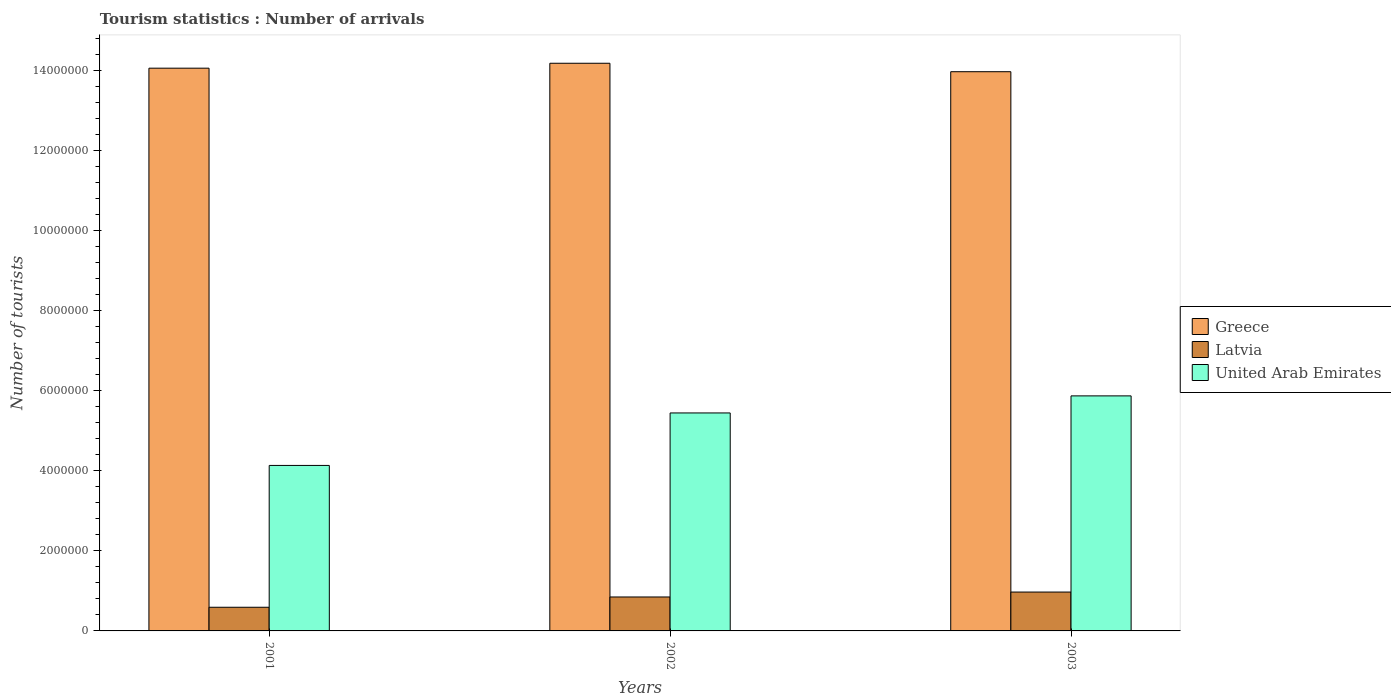How many different coloured bars are there?
Provide a short and direct response. 3. How many groups of bars are there?
Provide a succinct answer. 3. How many bars are there on the 2nd tick from the left?
Provide a short and direct response. 3. How many bars are there on the 1st tick from the right?
Make the answer very short. 3. In how many cases, is the number of bars for a given year not equal to the number of legend labels?
Offer a very short reply. 0. What is the number of tourist arrivals in United Arab Emirates in 2003?
Offer a very short reply. 5.87e+06. Across all years, what is the maximum number of tourist arrivals in Latvia?
Provide a succinct answer. 9.71e+05. Across all years, what is the minimum number of tourist arrivals in Latvia?
Your answer should be compact. 5.91e+05. In which year was the number of tourist arrivals in United Arab Emirates minimum?
Your answer should be very brief. 2001. What is the total number of tourist arrivals in Greece in the graph?
Your answer should be compact. 4.22e+07. What is the difference between the number of tourist arrivals in Latvia in 2001 and that in 2003?
Ensure brevity in your answer.  -3.80e+05. What is the difference between the number of tourist arrivals in Latvia in 2001 and the number of tourist arrivals in Greece in 2002?
Ensure brevity in your answer.  -1.36e+07. What is the average number of tourist arrivals in Greece per year?
Make the answer very short. 1.41e+07. In the year 2001, what is the difference between the number of tourist arrivals in Latvia and number of tourist arrivals in United Arab Emirates?
Provide a succinct answer. -3.54e+06. What is the ratio of the number of tourist arrivals in Latvia in 2002 to that in 2003?
Your response must be concise. 0.87. Is the number of tourist arrivals in Greece in 2001 less than that in 2002?
Your answer should be compact. Yes. Is the difference between the number of tourist arrivals in Latvia in 2001 and 2003 greater than the difference between the number of tourist arrivals in United Arab Emirates in 2001 and 2003?
Your answer should be compact. Yes. What is the difference between the highest and the second highest number of tourist arrivals in Latvia?
Your answer should be compact. 1.23e+05. What is the difference between the highest and the lowest number of tourist arrivals in United Arab Emirates?
Provide a short and direct response. 1.74e+06. Is the sum of the number of tourist arrivals in Greece in 2002 and 2003 greater than the maximum number of tourist arrivals in Latvia across all years?
Make the answer very short. Yes. How many years are there in the graph?
Provide a succinct answer. 3. Are the values on the major ticks of Y-axis written in scientific E-notation?
Your answer should be very brief. No. Does the graph contain grids?
Your answer should be very brief. No. Where does the legend appear in the graph?
Ensure brevity in your answer.  Center right. How many legend labels are there?
Offer a very short reply. 3. How are the legend labels stacked?
Offer a very short reply. Vertical. What is the title of the graph?
Provide a short and direct response. Tourism statistics : Number of arrivals. Does "Iceland" appear as one of the legend labels in the graph?
Make the answer very short. No. What is the label or title of the Y-axis?
Make the answer very short. Number of tourists. What is the Number of tourists of Greece in 2001?
Provide a succinct answer. 1.41e+07. What is the Number of tourists in Latvia in 2001?
Ensure brevity in your answer.  5.91e+05. What is the Number of tourists in United Arab Emirates in 2001?
Provide a short and direct response. 4.13e+06. What is the Number of tourists of Greece in 2002?
Make the answer very short. 1.42e+07. What is the Number of tourists of Latvia in 2002?
Provide a short and direct response. 8.48e+05. What is the Number of tourists of United Arab Emirates in 2002?
Provide a short and direct response. 5.44e+06. What is the Number of tourists in Greece in 2003?
Provide a short and direct response. 1.40e+07. What is the Number of tourists in Latvia in 2003?
Make the answer very short. 9.71e+05. What is the Number of tourists of United Arab Emirates in 2003?
Provide a succinct answer. 5.87e+06. Across all years, what is the maximum Number of tourists of Greece?
Your answer should be very brief. 1.42e+07. Across all years, what is the maximum Number of tourists of Latvia?
Your answer should be compact. 9.71e+05. Across all years, what is the maximum Number of tourists in United Arab Emirates?
Your answer should be compact. 5.87e+06. Across all years, what is the minimum Number of tourists in Greece?
Give a very brief answer. 1.40e+07. Across all years, what is the minimum Number of tourists in Latvia?
Ensure brevity in your answer.  5.91e+05. Across all years, what is the minimum Number of tourists of United Arab Emirates?
Keep it short and to the point. 4.13e+06. What is the total Number of tourists of Greece in the graph?
Your answer should be compact. 4.22e+07. What is the total Number of tourists in Latvia in the graph?
Offer a very short reply. 2.41e+06. What is the total Number of tourists in United Arab Emirates in the graph?
Keep it short and to the point. 1.54e+07. What is the difference between the Number of tourists in Greece in 2001 and that in 2002?
Offer a very short reply. -1.23e+05. What is the difference between the Number of tourists in Latvia in 2001 and that in 2002?
Offer a terse response. -2.57e+05. What is the difference between the Number of tourists of United Arab Emirates in 2001 and that in 2002?
Provide a succinct answer. -1.31e+06. What is the difference between the Number of tourists in Greece in 2001 and that in 2003?
Give a very brief answer. 8.80e+04. What is the difference between the Number of tourists in Latvia in 2001 and that in 2003?
Ensure brevity in your answer.  -3.80e+05. What is the difference between the Number of tourists in United Arab Emirates in 2001 and that in 2003?
Offer a terse response. -1.74e+06. What is the difference between the Number of tourists in Greece in 2002 and that in 2003?
Offer a terse response. 2.11e+05. What is the difference between the Number of tourists of Latvia in 2002 and that in 2003?
Keep it short and to the point. -1.23e+05. What is the difference between the Number of tourists in United Arab Emirates in 2002 and that in 2003?
Offer a very short reply. -4.26e+05. What is the difference between the Number of tourists in Greece in 2001 and the Number of tourists in Latvia in 2002?
Ensure brevity in your answer.  1.32e+07. What is the difference between the Number of tourists of Greece in 2001 and the Number of tourists of United Arab Emirates in 2002?
Offer a very short reply. 8.61e+06. What is the difference between the Number of tourists of Latvia in 2001 and the Number of tourists of United Arab Emirates in 2002?
Your answer should be compact. -4.85e+06. What is the difference between the Number of tourists in Greece in 2001 and the Number of tourists in Latvia in 2003?
Make the answer very short. 1.31e+07. What is the difference between the Number of tourists of Greece in 2001 and the Number of tourists of United Arab Emirates in 2003?
Provide a short and direct response. 8.19e+06. What is the difference between the Number of tourists in Latvia in 2001 and the Number of tourists in United Arab Emirates in 2003?
Provide a short and direct response. -5.28e+06. What is the difference between the Number of tourists in Greece in 2002 and the Number of tourists in Latvia in 2003?
Make the answer very short. 1.32e+07. What is the difference between the Number of tourists in Greece in 2002 and the Number of tourists in United Arab Emirates in 2003?
Ensure brevity in your answer.  8.31e+06. What is the difference between the Number of tourists in Latvia in 2002 and the Number of tourists in United Arab Emirates in 2003?
Your answer should be compact. -5.02e+06. What is the average Number of tourists of Greece per year?
Your answer should be compact. 1.41e+07. What is the average Number of tourists in Latvia per year?
Your response must be concise. 8.03e+05. What is the average Number of tourists of United Arab Emirates per year?
Offer a terse response. 5.15e+06. In the year 2001, what is the difference between the Number of tourists in Greece and Number of tourists in Latvia?
Give a very brief answer. 1.35e+07. In the year 2001, what is the difference between the Number of tourists of Greece and Number of tourists of United Arab Emirates?
Give a very brief answer. 9.92e+06. In the year 2001, what is the difference between the Number of tourists of Latvia and Number of tourists of United Arab Emirates?
Your answer should be very brief. -3.54e+06. In the year 2002, what is the difference between the Number of tourists in Greece and Number of tourists in Latvia?
Your answer should be compact. 1.33e+07. In the year 2002, what is the difference between the Number of tourists of Greece and Number of tourists of United Arab Emirates?
Offer a very short reply. 8.74e+06. In the year 2002, what is the difference between the Number of tourists of Latvia and Number of tourists of United Arab Emirates?
Give a very brief answer. -4.60e+06. In the year 2003, what is the difference between the Number of tourists of Greece and Number of tourists of Latvia?
Provide a succinct answer. 1.30e+07. In the year 2003, what is the difference between the Number of tourists in Greece and Number of tourists in United Arab Emirates?
Ensure brevity in your answer.  8.10e+06. In the year 2003, what is the difference between the Number of tourists in Latvia and Number of tourists in United Arab Emirates?
Provide a succinct answer. -4.90e+06. What is the ratio of the Number of tourists of Latvia in 2001 to that in 2002?
Make the answer very short. 0.7. What is the ratio of the Number of tourists of United Arab Emirates in 2001 to that in 2002?
Keep it short and to the point. 0.76. What is the ratio of the Number of tourists in Greece in 2001 to that in 2003?
Keep it short and to the point. 1.01. What is the ratio of the Number of tourists in Latvia in 2001 to that in 2003?
Offer a very short reply. 0.61. What is the ratio of the Number of tourists in United Arab Emirates in 2001 to that in 2003?
Your response must be concise. 0.7. What is the ratio of the Number of tourists in Greece in 2002 to that in 2003?
Give a very brief answer. 1.02. What is the ratio of the Number of tourists in Latvia in 2002 to that in 2003?
Offer a very short reply. 0.87. What is the ratio of the Number of tourists in United Arab Emirates in 2002 to that in 2003?
Provide a short and direct response. 0.93. What is the difference between the highest and the second highest Number of tourists of Greece?
Keep it short and to the point. 1.23e+05. What is the difference between the highest and the second highest Number of tourists in Latvia?
Make the answer very short. 1.23e+05. What is the difference between the highest and the second highest Number of tourists of United Arab Emirates?
Keep it short and to the point. 4.26e+05. What is the difference between the highest and the lowest Number of tourists in Greece?
Provide a short and direct response. 2.11e+05. What is the difference between the highest and the lowest Number of tourists of United Arab Emirates?
Provide a succinct answer. 1.74e+06. 